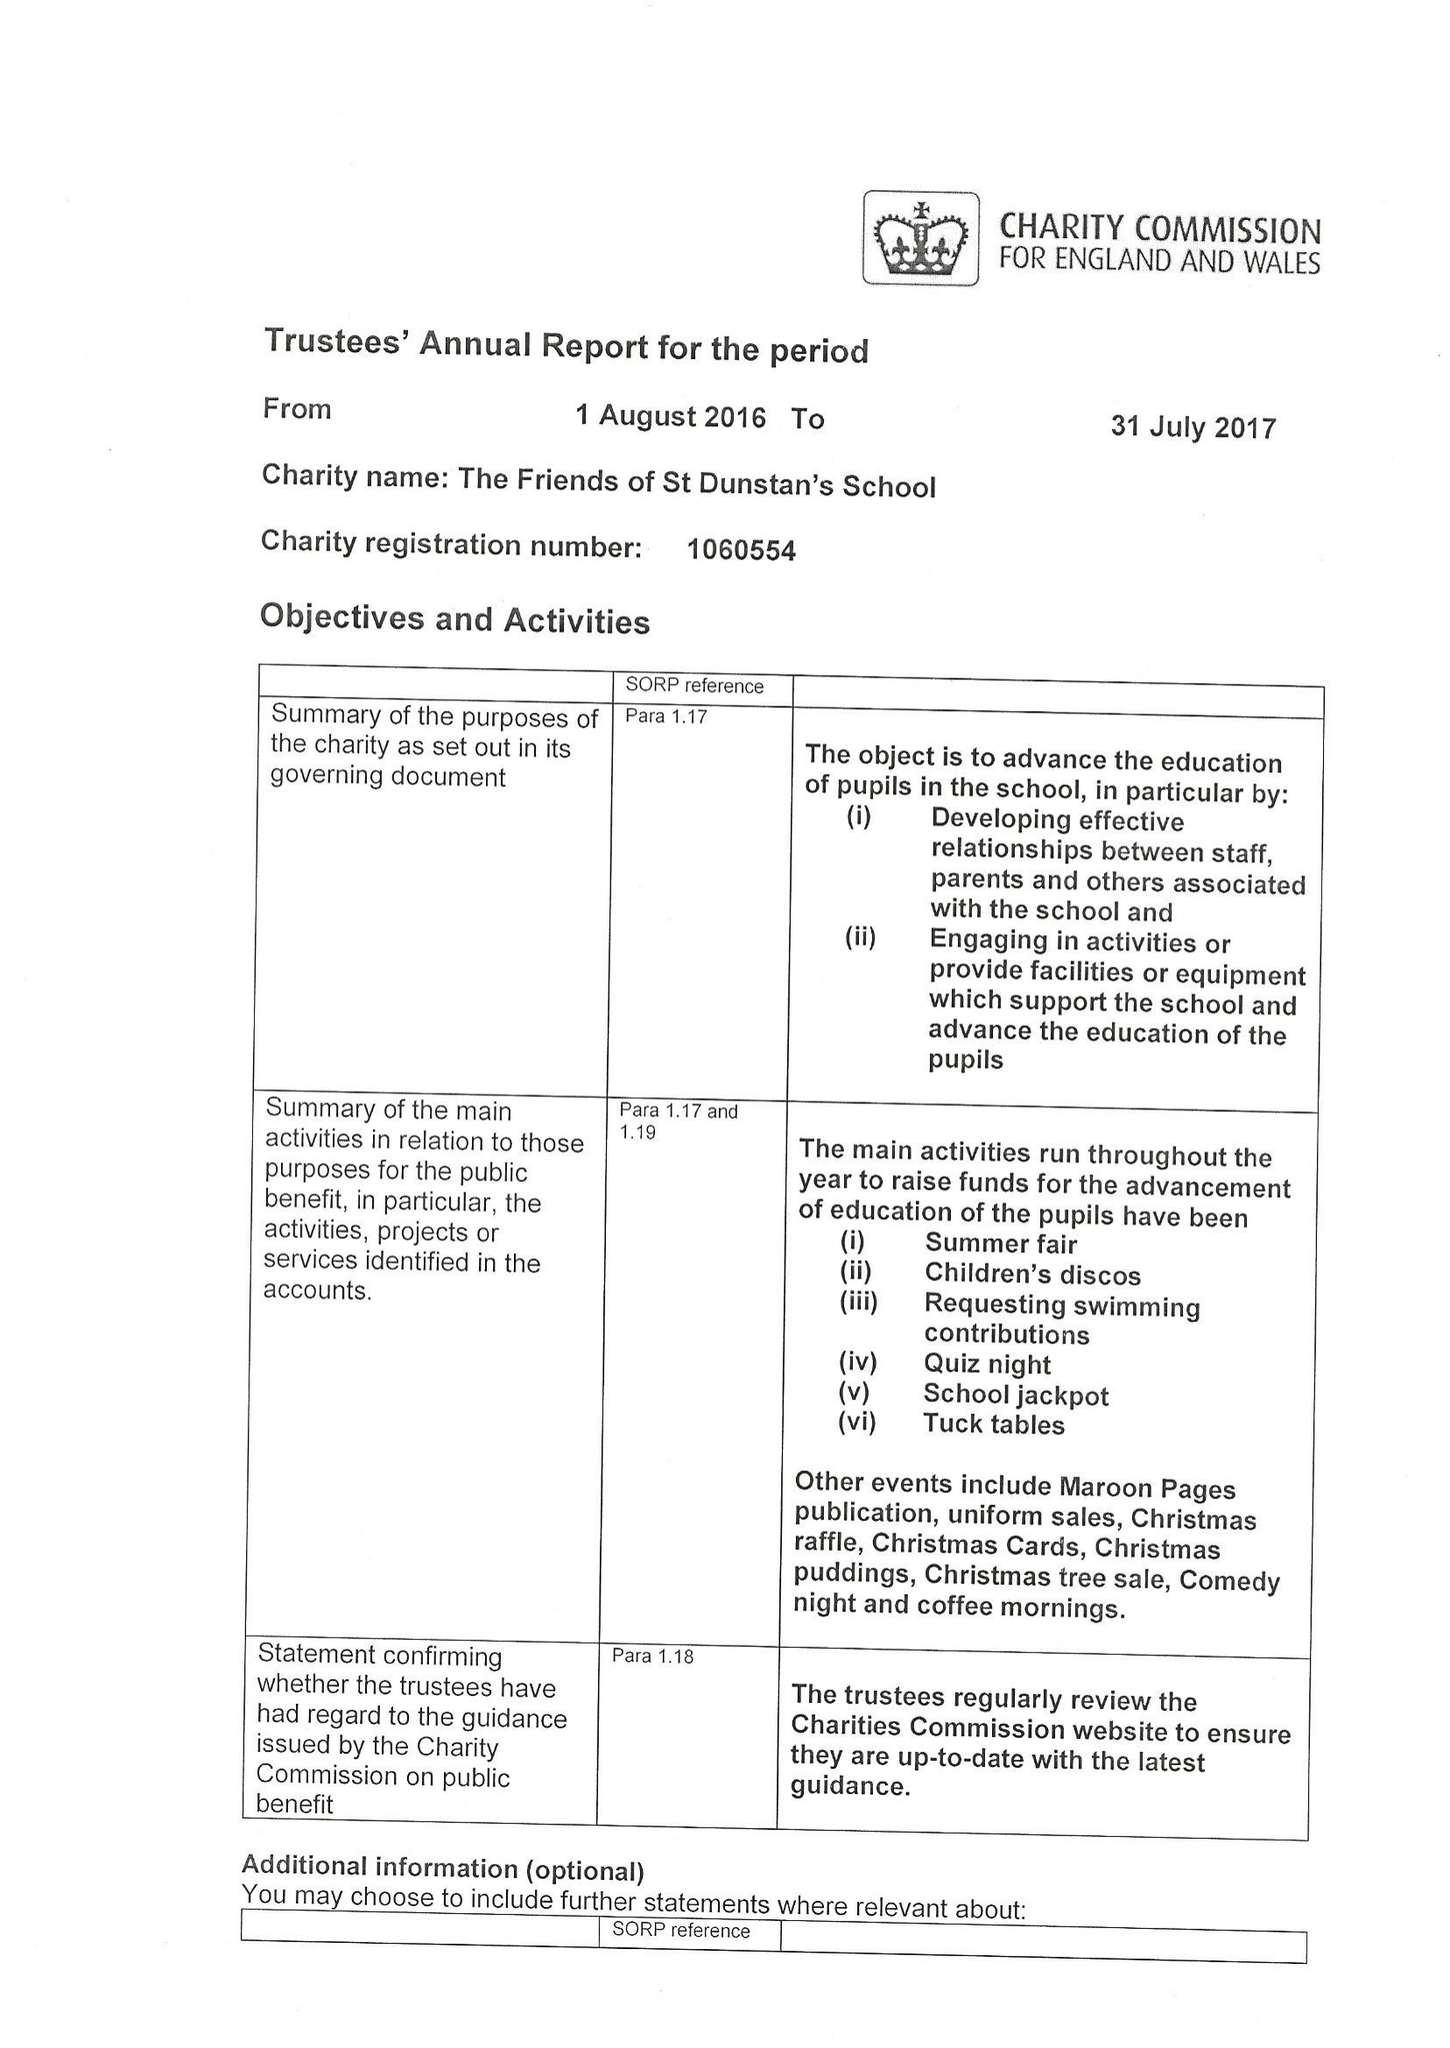What is the value for the charity_name?
Answer the question using a single word or phrase. The Friends Of St Dunstan's School 